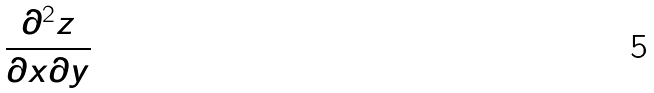Convert formula to latex. <formula><loc_0><loc_0><loc_500><loc_500>\frac { \partial ^ { 2 } z } { \partial x \partial y }</formula> 